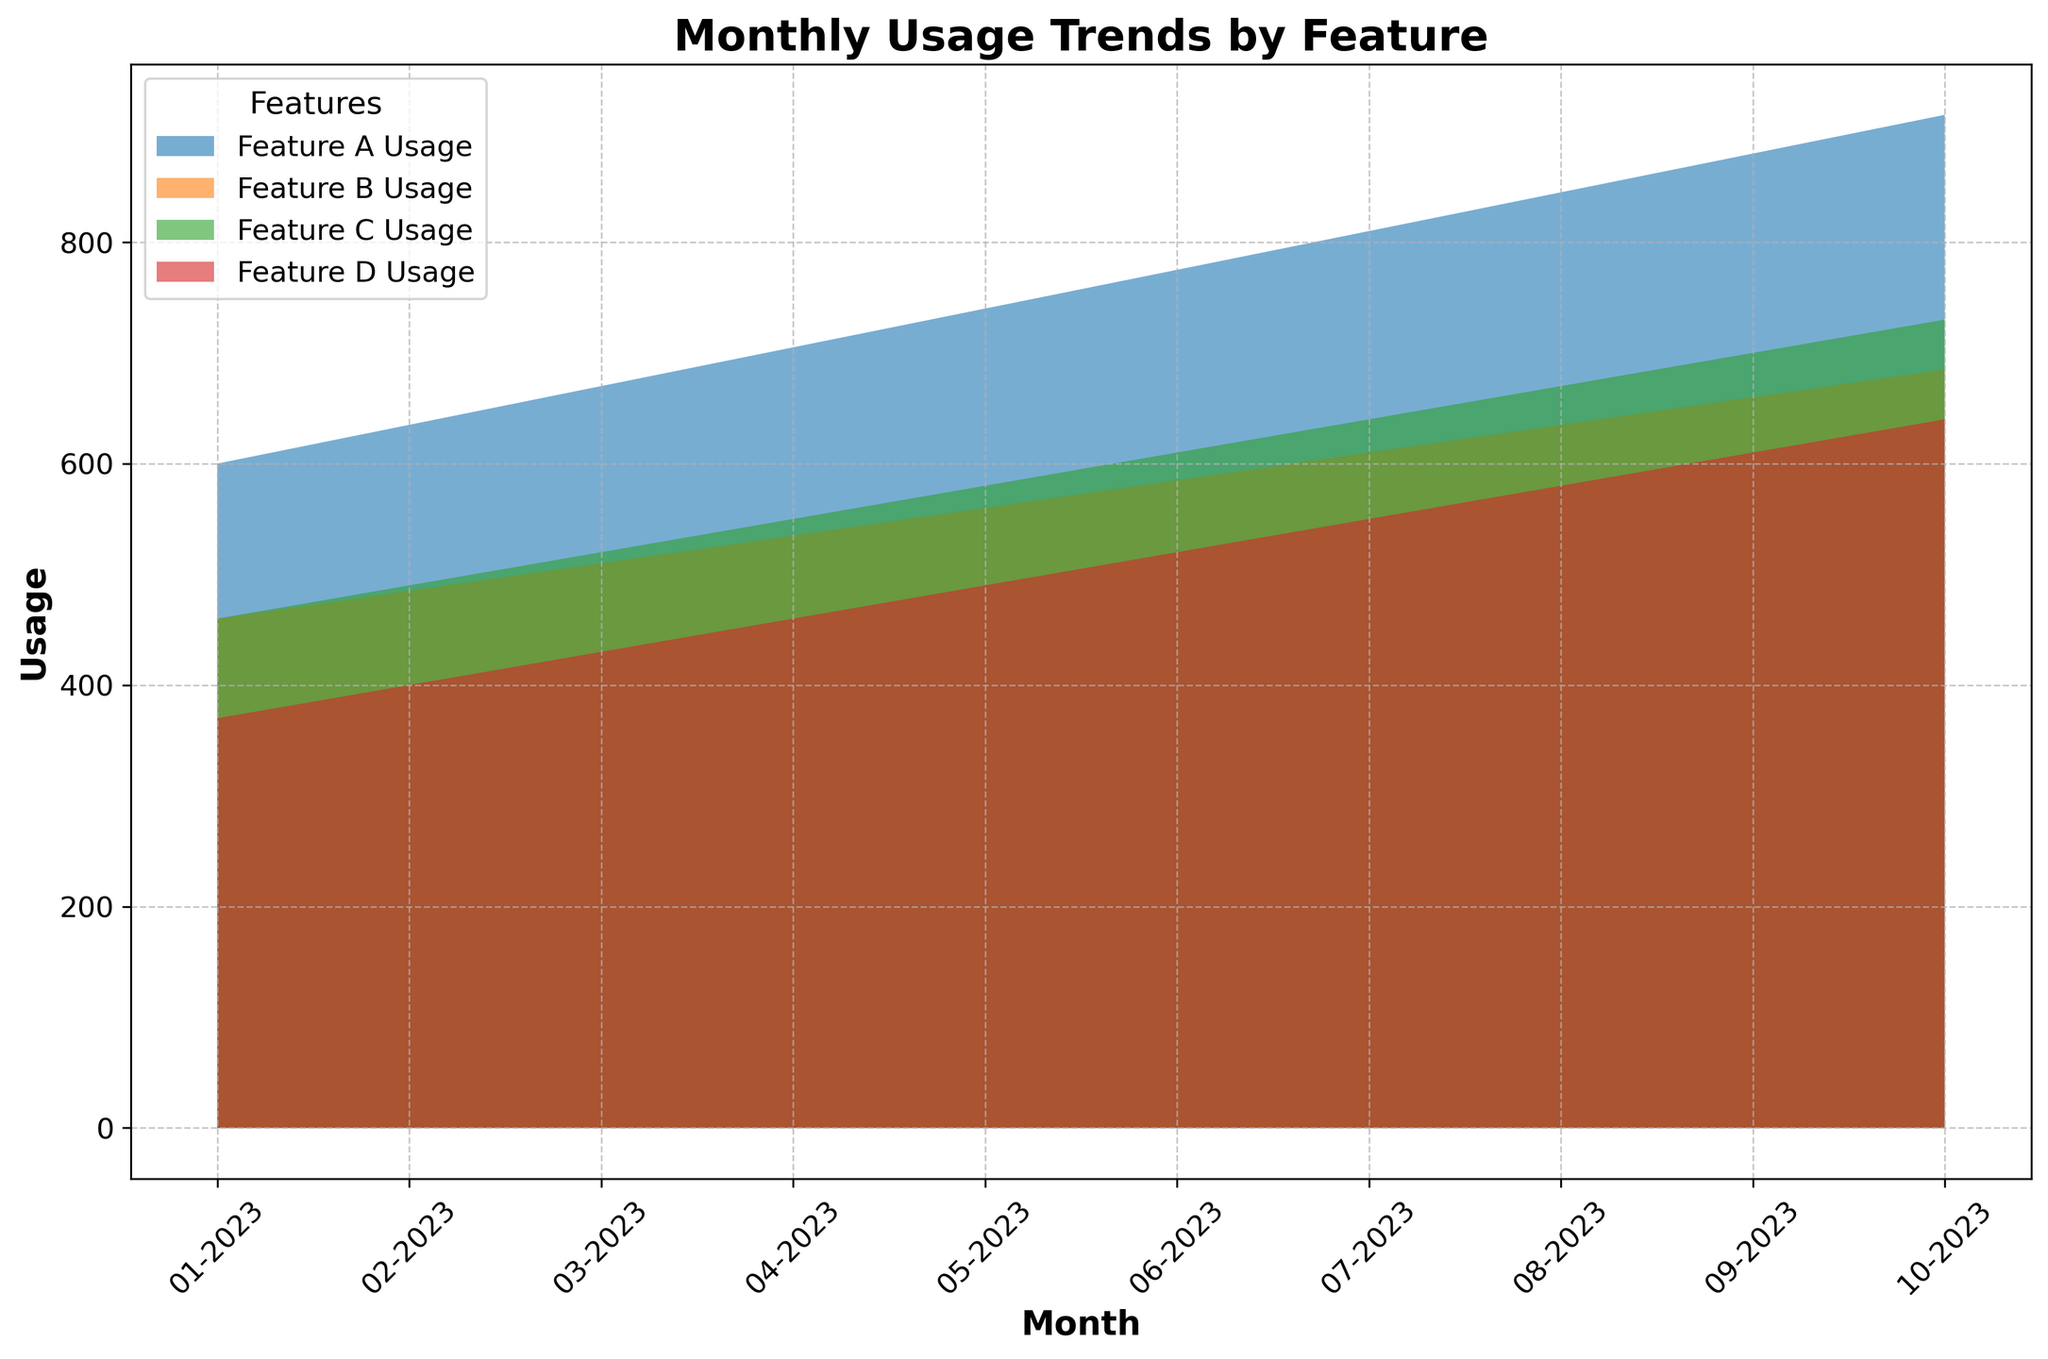What trend do you observe in Feature A usage across all age groups from January to October 2023? The area for Feature A usage is gradually increasing over the months, indicating a rising trend in Feature A usage across all age groups.
Answer: Increasing trend Which feature had the highest usage in April 2023? By comparing the visual areas for April 2023, Feature A shows the highest usage, as it covers the largest area among all features.
Answer: Feature A How does the total usage of Feature B in April 2023 compare to its total usage in January 2023? The visual area for Feature B in April appears larger than in January, suggesting the usage has increased.
Answer: Increased Which age group contributed to the highest usage of Feature C in October 2023? By closely observing the stack heights, the 18-25 age group has the highest contribution as it is at the bottom and has the thickest segment in October 2023.
Answer: Age group 18-25 What’s the range of Feature D usage by the 46-55 age group from January to October 2023? Looking at the height of Feature D for the 46-55 age group from January to October, the usage fluctuated between around 60 to 105 units.
Answer: 60 to 105 units Calculate the average monthly usage of Feature B from January to October 2023. Summing up the monthly usage of Feature B and dividing by the number of months: (80+100+120+90+70+85+105+75+55+100+110+90+85+125+105+130+110+115+100+135+145) / 10. The total is 1480, so the average is 1480/10.
Answer: 148 Is there a month where all features experienced usage growth compared to the previous month? Checking visually, from January to February and subsequently, all feature areas increased consistently from month to month without backtracking.
Answer: February, March Between March 2023 and September 2023, which feature showed the most significant increase in usage? By comparing respective areas, Feature A has shown the most significant consistent increase in its area.
Answer: Feature A Compare the usage of Feature C and Feature D for the age group 36-45 in July 2023. Feature C has a higher area/height for the age group 36-45 in July compared to Feature D.
Answer: Feature C higher than Feature D What’s the median monthly usage of Feature A? Listing the monthly usage of Feature A: [120, 130, 140, 150, 160, 170, 180, 190, 200, 210]. Sorting them is the same, and the median is the middle value of the ordered list: (160+170)/2.
Answer: 165 